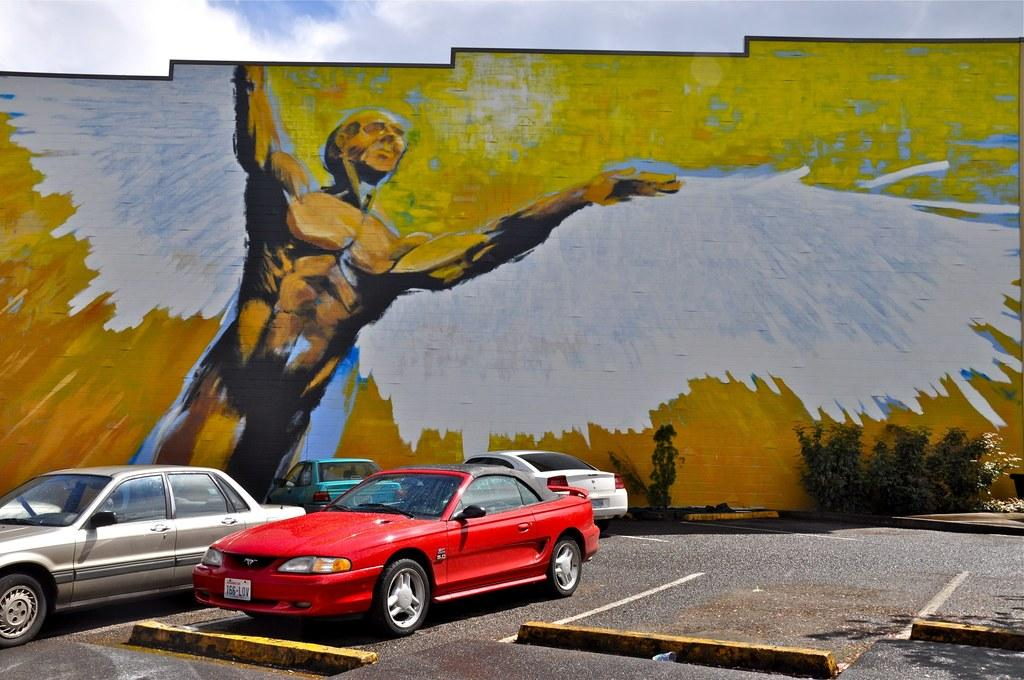What types of objects can be seen in the image? There are vehicles and plants visible in the image. What road feature can be seen in the image? There are speed breakers on the road in the image. What is present on a wall in the background of the image? There is a painting on a wall in the background of the image. What is visible in the sky at the top of the image? There are clouds visible in the sky at the top of the image. What type of linen is used to cover the vehicles in the image? There is no linen present in the image, and the vehicles are not covered. What writing instrument is being used by the clouds in the sky? There are no clouds using any writing instruments in the image; clouds are natural atmospheric phenomena. 